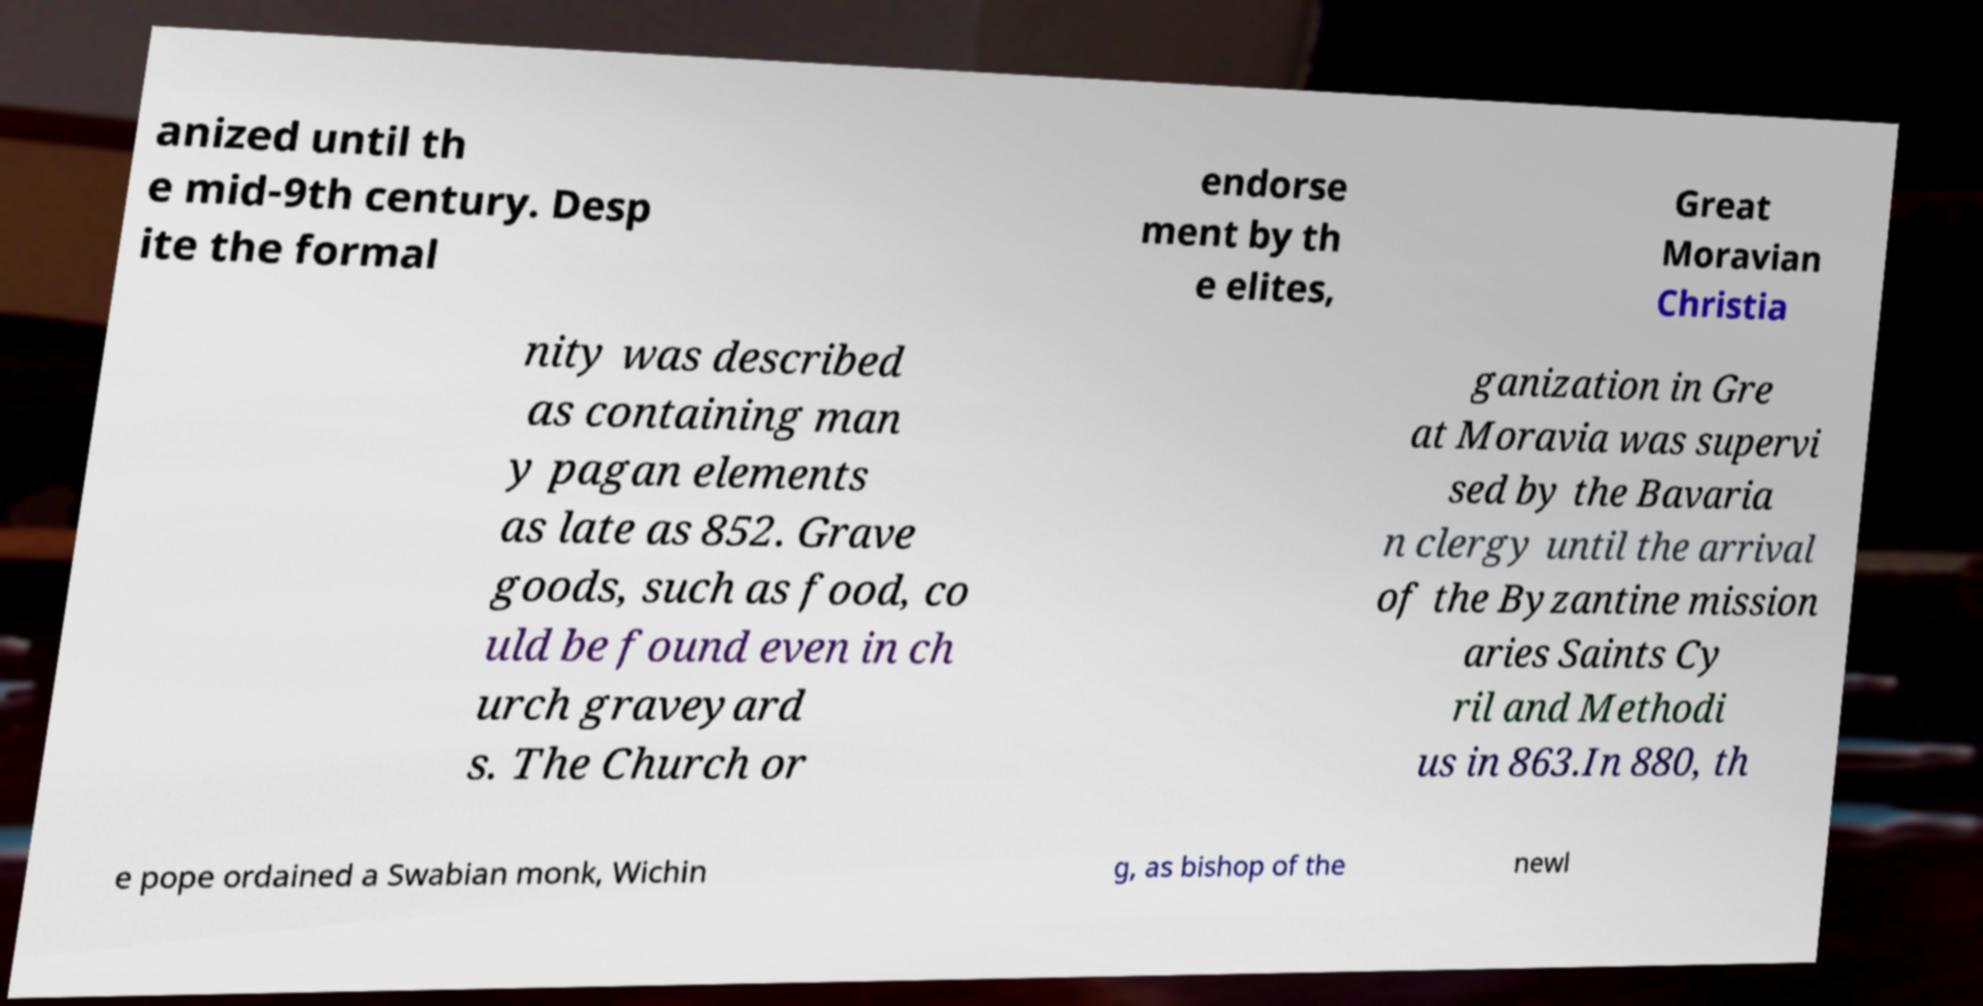There's text embedded in this image that I need extracted. Can you transcribe it verbatim? anized until th e mid-9th century. Desp ite the formal endorse ment by th e elites, Great Moravian Christia nity was described as containing man y pagan elements as late as 852. Grave goods, such as food, co uld be found even in ch urch graveyard s. The Church or ganization in Gre at Moravia was supervi sed by the Bavaria n clergy until the arrival of the Byzantine mission aries Saints Cy ril and Methodi us in 863.In 880, th e pope ordained a Swabian monk, Wichin g, as bishop of the newl 